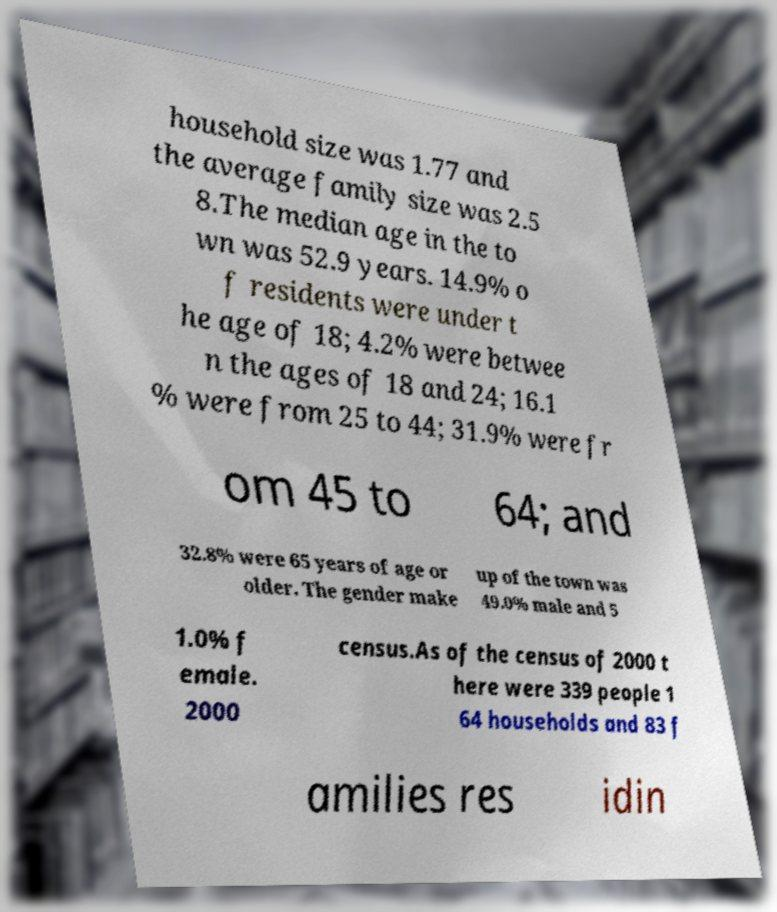Can you read and provide the text displayed in the image?This photo seems to have some interesting text. Can you extract and type it out for me? household size was 1.77 and the average family size was 2.5 8.The median age in the to wn was 52.9 years. 14.9% o f residents were under t he age of 18; 4.2% were betwee n the ages of 18 and 24; 16.1 % were from 25 to 44; 31.9% were fr om 45 to 64; and 32.8% were 65 years of age or older. The gender make up of the town was 49.0% male and 5 1.0% f emale. 2000 census.As of the census of 2000 t here were 339 people 1 64 households and 83 f amilies res idin 